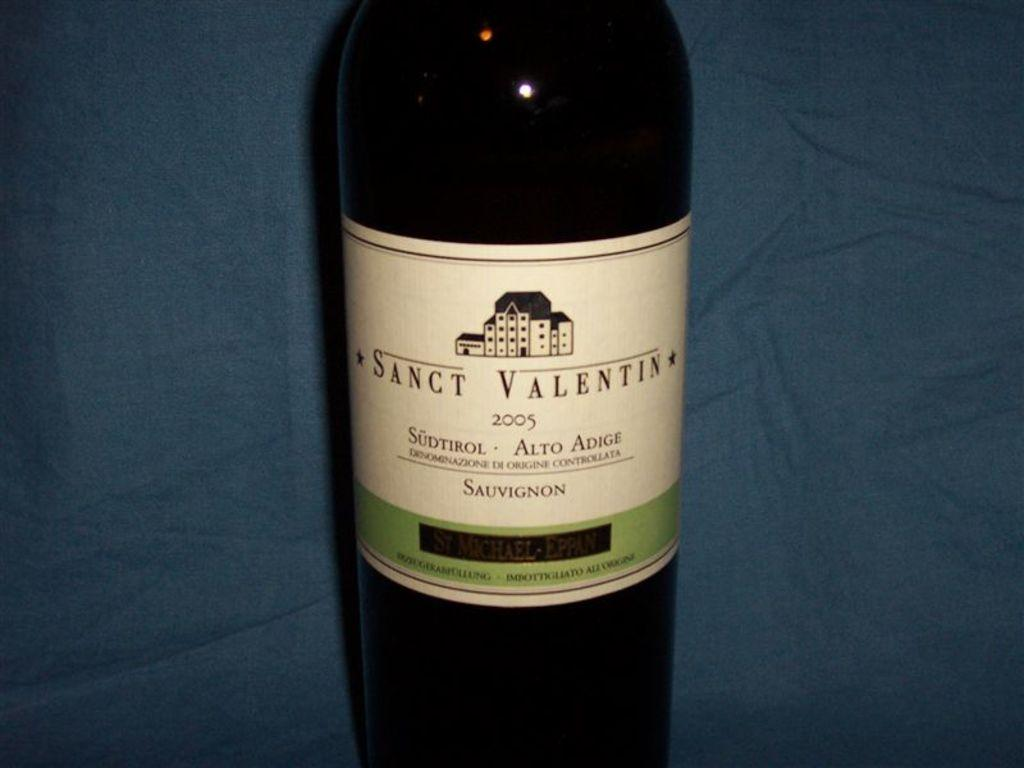<image>
Share a concise interpretation of the image provided. A bottle of Sanct Valentin has the year 2005 on it's label. 